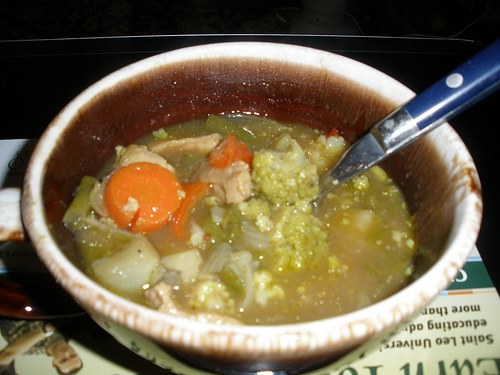What is the food to the right of the white onion called? The food to the right of the white onion is soup. 